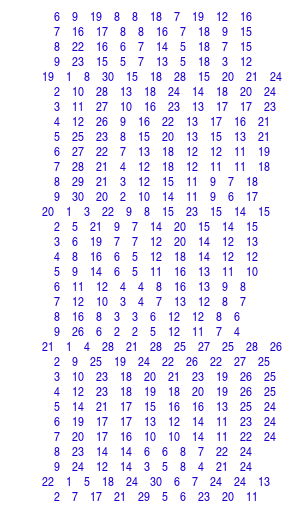<code> <loc_0><loc_0><loc_500><loc_500><_ObjectiveC_>	6	9	19	8	8	18	7	19	12	16	
	7	16	17	8	8	16	7	18	9	15	
	8	22	16	6	7	14	5	18	7	15	
	9	23	15	5	7	13	5	18	3	12	
19	1	8	30	15	18	28	15	20	21	24	
	2	10	28	13	18	24	14	18	20	24	
	3	11	27	10	16	23	13	17	17	23	
	4	12	26	9	16	22	13	17	16	21	
	5	25	23	8	15	20	13	15	13	21	
	6	27	22	7	13	18	12	12	11	19	
	7	28	21	4	12	18	12	11	11	18	
	8	29	21	3	12	15	11	9	7	18	
	9	30	20	2	10	14	11	9	6	17	
20	1	3	22	9	8	15	23	15	14	15	
	2	5	21	9	7	14	20	15	14	15	
	3	6	19	7	7	12	20	14	12	13	
	4	8	16	6	5	12	18	14	12	12	
	5	9	14	6	5	11	16	13	11	10	
	6	11	12	4	4	8	16	13	9	8	
	7	12	10	3	4	7	13	12	8	7	
	8	16	8	3	3	6	12	12	8	6	
	9	26	6	2	2	5	12	11	7	4	
21	1	4	28	21	28	25	27	25	28	26	
	2	9	25	19	24	22	26	22	27	25	
	3	10	23	18	20	21	23	19	26	25	
	4	12	23	18	19	18	20	19	26	25	
	5	14	21	17	15	16	16	13	25	24	
	6	19	17	17	13	12	14	11	23	24	
	7	20	17	16	10	10	14	11	22	24	
	8	23	14	14	6	6	8	7	22	24	
	9	24	12	14	3	5	8	4	21	24	
22	1	5	18	24	30	6	7	24	24	13	
	2	7	17	21	29	5	6	23	20	11	</code> 